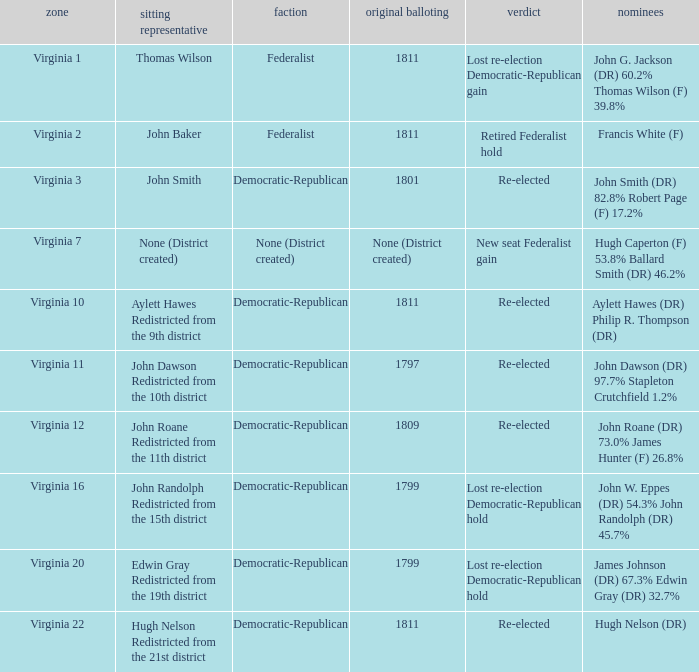Name the party for virginia 12 Democratic-Republican. Write the full table. {'header': ['zone', 'sitting representative', 'faction', 'original balloting', 'verdict', 'nominees'], 'rows': [['Virginia 1', 'Thomas Wilson', 'Federalist', '1811', 'Lost re-election Democratic-Republican gain', 'John G. Jackson (DR) 60.2% Thomas Wilson (F) 39.8%'], ['Virginia 2', 'John Baker', 'Federalist', '1811', 'Retired Federalist hold', 'Francis White (F)'], ['Virginia 3', 'John Smith', 'Democratic-Republican', '1801', 'Re-elected', 'John Smith (DR) 82.8% Robert Page (F) 17.2%'], ['Virginia 7', 'None (District created)', 'None (District created)', 'None (District created)', 'New seat Federalist gain', 'Hugh Caperton (F) 53.8% Ballard Smith (DR) 46.2%'], ['Virginia 10', 'Aylett Hawes Redistricted from the 9th district', 'Democratic-Republican', '1811', 'Re-elected', 'Aylett Hawes (DR) Philip R. Thompson (DR)'], ['Virginia 11', 'John Dawson Redistricted from the 10th district', 'Democratic-Republican', '1797', 'Re-elected', 'John Dawson (DR) 97.7% Stapleton Crutchfield 1.2%'], ['Virginia 12', 'John Roane Redistricted from the 11th district', 'Democratic-Republican', '1809', 'Re-elected', 'John Roane (DR) 73.0% James Hunter (F) 26.8%'], ['Virginia 16', 'John Randolph Redistricted from the 15th district', 'Democratic-Republican', '1799', 'Lost re-election Democratic-Republican hold', 'John W. Eppes (DR) 54.3% John Randolph (DR) 45.7%'], ['Virginia 20', 'Edwin Gray Redistricted from the 19th district', 'Democratic-Republican', '1799', 'Lost re-election Democratic-Republican hold', 'James Johnson (DR) 67.3% Edwin Gray (DR) 32.7%'], ['Virginia 22', 'Hugh Nelson Redistricted from the 21st district', 'Democratic-Republican', '1811', 'Re-elected', 'Hugh Nelson (DR)']]} 